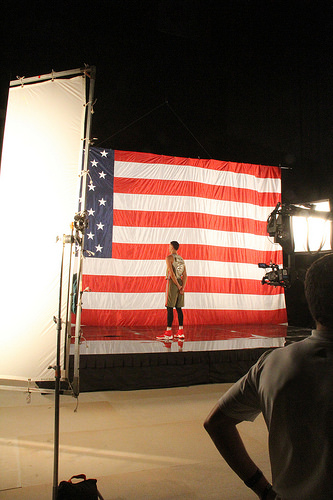<image>
Can you confirm if the man is on the flag? No. The man is not positioned on the flag. They may be near each other, but the man is not supported by or resting on top of the flag. Is the man behind the flag? No. The man is not behind the flag. From this viewpoint, the man appears to be positioned elsewhere in the scene. Is there a shoe in front of the man? No. The shoe is not in front of the man. The spatial positioning shows a different relationship between these objects. 